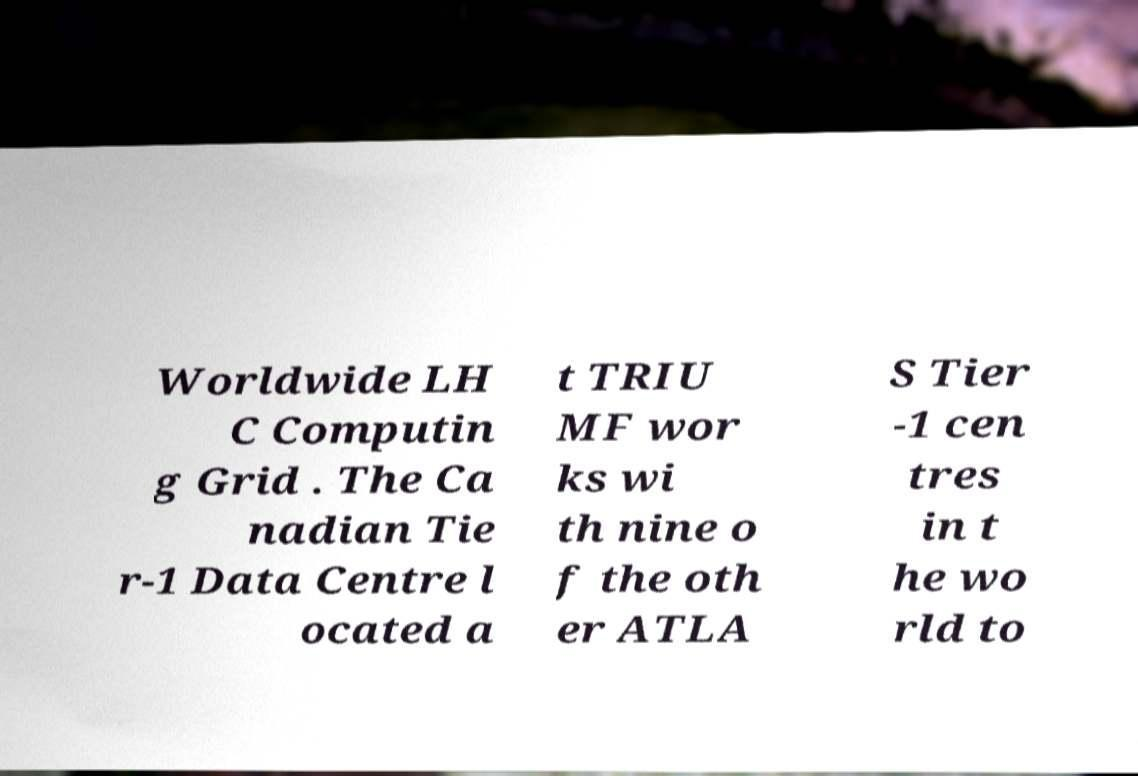There's text embedded in this image that I need extracted. Can you transcribe it verbatim? Worldwide LH C Computin g Grid . The Ca nadian Tie r-1 Data Centre l ocated a t TRIU MF wor ks wi th nine o f the oth er ATLA S Tier -1 cen tres in t he wo rld to 